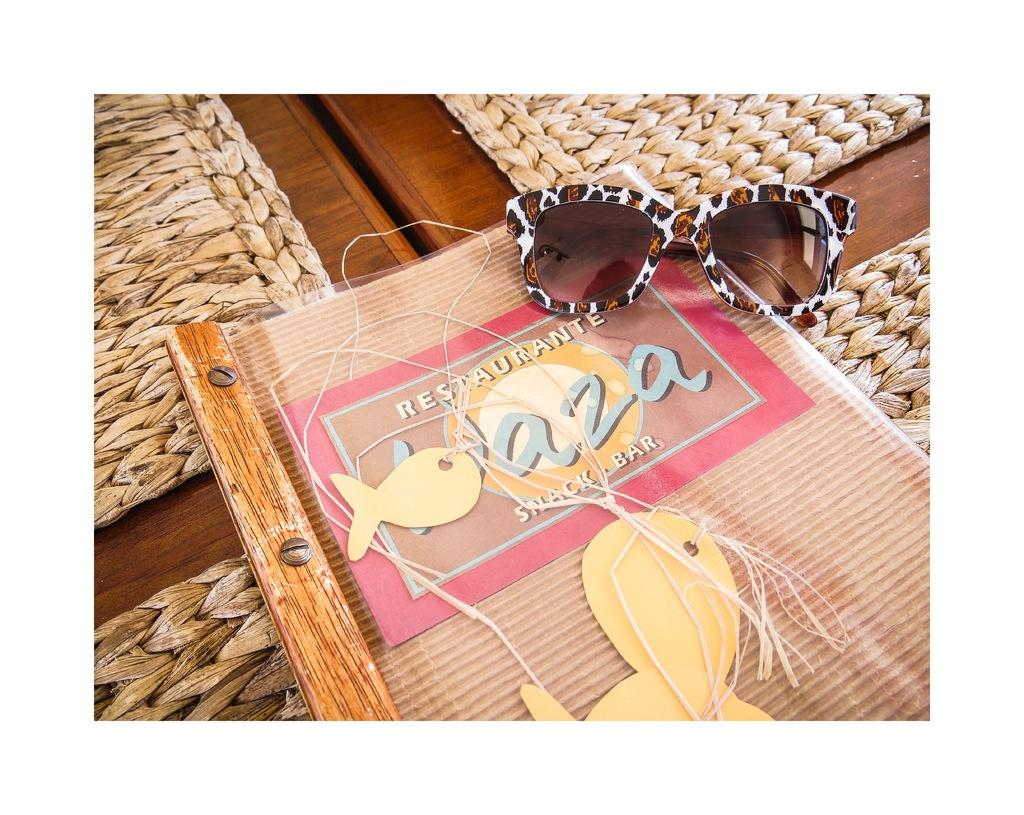What is the primary object featured in the image? There is a menu in the image. What accessory can be seen in the image? There are sunglasses in the image. What type of surface is visible in the image? There is a wooden surface in the image. What other objects are present at the bottom of the image? There are other objects at the bottom of the image, but their specific details are not mentioned in the provided facts. What type of rail can be seen in the image? There is no rail present in the image. Can you see the moon in the image? The moon is not visible in the image. 